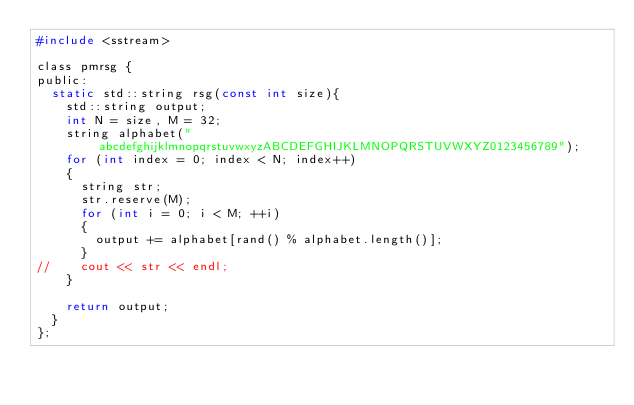<code> <loc_0><loc_0><loc_500><loc_500><_C_>#include <sstream>

class pmrsg {
public:
	static std::string rsg(const int size){
		std::string output;
    int N = size, M = 32;
    string alphabet("abcdefghijklmnopqrstuvwxyzABCDEFGHIJKLMNOPQRSTUVWXYZ0123456789");
    for (int index = 0; index < N; index++)
    {
      string str;
      str.reserve(M);
      for (int i = 0; i < M; ++i)
      {
        output += alphabet[rand() % alphabet.length()];
      }
//    cout << str << endl;
    } 

		return output;
	}
};

</code> 